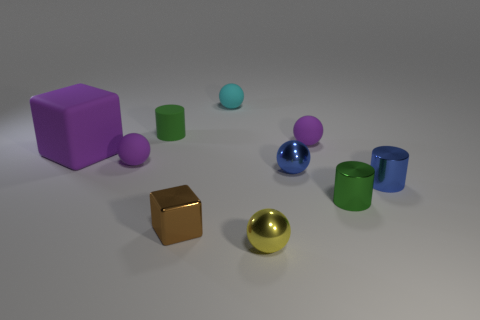Subtract all purple balls. How many balls are left? 3 Subtract all blue metallic spheres. How many spheres are left? 4 Subtract all gray spheres. Subtract all cyan blocks. How many spheres are left? 5 Subtract all cubes. How many objects are left? 8 Add 3 small brown metal things. How many small brown metal things exist? 4 Subtract 1 brown blocks. How many objects are left? 9 Subtract all purple cubes. Subtract all small yellow balls. How many objects are left? 8 Add 8 large purple rubber blocks. How many large purple rubber blocks are left? 9 